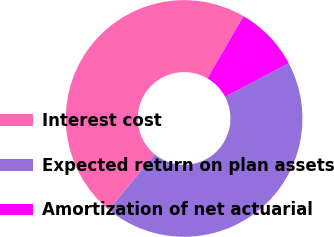<chart> <loc_0><loc_0><loc_500><loc_500><pie_chart><fcel>Interest cost<fcel>Expected return on plan assets<fcel>Amortization of net actuarial<nl><fcel>47.41%<fcel>43.7%<fcel>8.89%<nl></chart> 